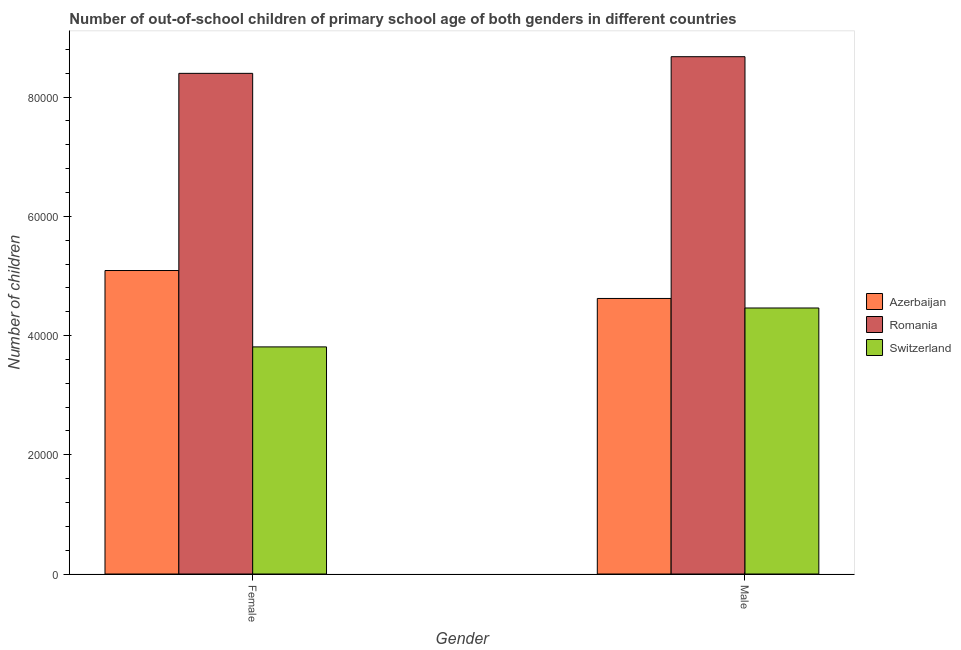How many different coloured bars are there?
Your answer should be compact. 3. How many groups of bars are there?
Offer a very short reply. 2. How many bars are there on the 2nd tick from the left?
Provide a short and direct response. 3. What is the label of the 2nd group of bars from the left?
Your answer should be very brief. Male. What is the number of female out-of-school students in Romania?
Offer a very short reply. 8.40e+04. Across all countries, what is the maximum number of male out-of-school students?
Give a very brief answer. 8.68e+04. Across all countries, what is the minimum number of female out-of-school students?
Provide a short and direct response. 3.81e+04. In which country was the number of male out-of-school students maximum?
Your response must be concise. Romania. In which country was the number of male out-of-school students minimum?
Ensure brevity in your answer.  Switzerland. What is the total number of male out-of-school students in the graph?
Give a very brief answer. 1.78e+05. What is the difference between the number of male out-of-school students in Romania and that in Azerbaijan?
Offer a very short reply. 4.06e+04. What is the difference between the number of female out-of-school students in Romania and the number of male out-of-school students in Azerbaijan?
Offer a terse response. 3.78e+04. What is the average number of male out-of-school students per country?
Offer a very short reply. 5.92e+04. What is the difference between the number of female out-of-school students and number of male out-of-school students in Azerbaijan?
Make the answer very short. 4686. What is the ratio of the number of female out-of-school students in Romania to that in Switzerland?
Give a very brief answer. 2.2. In how many countries, is the number of male out-of-school students greater than the average number of male out-of-school students taken over all countries?
Your answer should be compact. 1. What does the 3rd bar from the left in Male represents?
Provide a succinct answer. Switzerland. What does the 3rd bar from the right in Female represents?
Your response must be concise. Azerbaijan. How many bars are there?
Make the answer very short. 6. Are all the bars in the graph horizontal?
Make the answer very short. No. How many countries are there in the graph?
Make the answer very short. 3. Are the values on the major ticks of Y-axis written in scientific E-notation?
Your answer should be very brief. No. Does the graph contain any zero values?
Keep it short and to the point. No. Does the graph contain grids?
Offer a very short reply. No. What is the title of the graph?
Your answer should be very brief. Number of out-of-school children of primary school age of both genders in different countries. What is the label or title of the Y-axis?
Provide a short and direct response. Number of children. What is the Number of children of Azerbaijan in Female?
Your answer should be compact. 5.09e+04. What is the Number of children in Romania in Female?
Provide a succinct answer. 8.40e+04. What is the Number of children of Switzerland in Female?
Keep it short and to the point. 3.81e+04. What is the Number of children in Azerbaijan in Male?
Your response must be concise. 4.62e+04. What is the Number of children in Romania in Male?
Provide a short and direct response. 8.68e+04. What is the Number of children of Switzerland in Male?
Your answer should be very brief. 4.46e+04. Across all Gender, what is the maximum Number of children of Azerbaijan?
Offer a very short reply. 5.09e+04. Across all Gender, what is the maximum Number of children of Romania?
Give a very brief answer. 8.68e+04. Across all Gender, what is the maximum Number of children of Switzerland?
Make the answer very short. 4.46e+04. Across all Gender, what is the minimum Number of children in Azerbaijan?
Your answer should be compact. 4.62e+04. Across all Gender, what is the minimum Number of children in Romania?
Provide a succinct answer. 8.40e+04. Across all Gender, what is the minimum Number of children of Switzerland?
Give a very brief answer. 3.81e+04. What is the total Number of children in Azerbaijan in the graph?
Give a very brief answer. 9.71e+04. What is the total Number of children of Romania in the graph?
Make the answer very short. 1.71e+05. What is the total Number of children in Switzerland in the graph?
Keep it short and to the point. 8.27e+04. What is the difference between the Number of children in Azerbaijan in Female and that in Male?
Provide a succinct answer. 4686. What is the difference between the Number of children of Romania in Female and that in Male?
Your answer should be very brief. -2795. What is the difference between the Number of children in Switzerland in Female and that in Male?
Offer a terse response. -6526. What is the difference between the Number of children of Azerbaijan in Female and the Number of children of Romania in Male?
Ensure brevity in your answer.  -3.59e+04. What is the difference between the Number of children of Azerbaijan in Female and the Number of children of Switzerland in Male?
Provide a short and direct response. 6285. What is the difference between the Number of children in Romania in Female and the Number of children in Switzerland in Male?
Make the answer very short. 3.94e+04. What is the average Number of children in Azerbaijan per Gender?
Your response must be concise. 4.86e+04. What is the average Number of children in Romania per Gender?
Your answer should be very brief. 8.54e+04. What is the average Number of children in Switzerland per Gender?
Offer a terse response. 4.14e+04. What is the difference between the Number of children in Azerbaijan and Number of children in Romania in Female?
Ensure brevity in your answer.  -3.31e+04. What is the difference between the Number of children in Azerbaijan and Number of children in Switzerland in Female?
Your answer should be very brief. 1.28e+04. What is the difference between the Number of children in Romania and Number of children in Switzerland in Female?
Give a very brief answer. 4.59e+04. What is the difference between the Number of children of Azerbaijan and Number of children of Romania in Male?
Make the answer very short. -4.06e+04. What is the difference between the Number of children in Azerbaijan and Number of children in Switzerland in Male?
Make the answer very short. 1599. What is the difference between the Number of children in Romania and Number of children in Switzerland in Male?
Your answer should be compact. 4.22e+04. What is the ratio of the Number of children of Azerbaijan in Female to that in Male?
Your answer should be very brief. 1.1. What is the ratio of the Number of children of Romania in Female to that in Male?
Keep it short and to the point. 0.97. What is the ratio of the Number of children of Switzerland in Female to that in Male?
Provide a short and direct response. 0.85. What is the difference between the highest and the second highest Number of children of Azerbaijan?
Keep it short and to the point. 4686. What is the difference between the highest and the second highest Number of children of Romania?
Keep it short and to the point. 2795. What is the difference between the highest and the second highest Number of children of Switzerland?
Make the answer very short. 6526. What is the difference between the highest and the lowest Number of children in Azerbaijan?
Your response must be concise. 4686. What is the difference between the highest and the lowest Number of children of Romania?
Keep it short and to the point. 2795. What is the difference between the highest and the lowest Number of children of Switzerland?
Your answer should be very brief. 6526. 